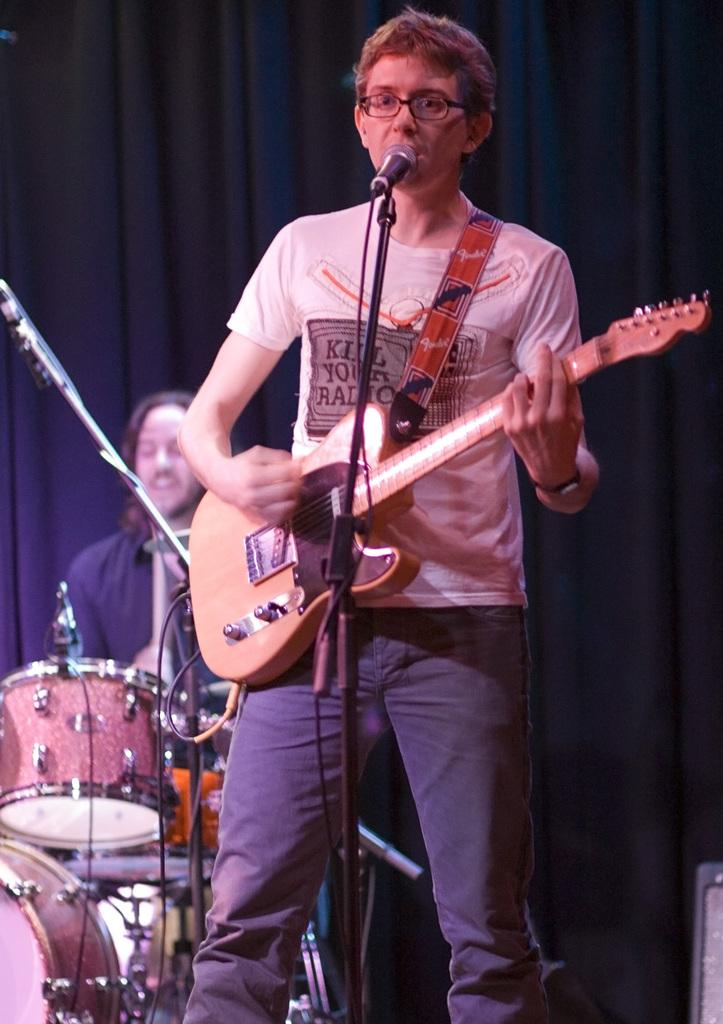What is the main subject of the image? The main subject of the image is a boy. What is the boy doing in the image? The boy is performing guitar play on the stage. What is the boy wearing in the image? The boy is wearing a white t-shirt. Can you describe the person behind the boy? The person behind the boy is playing a band. What can be seen in the background of the image? There is a blue curtain in the background. Is there a fire visible in the image? No, there is no fire present in the image. Can you see a card being held by the boy in the image? No, there is no card visible in the image. 